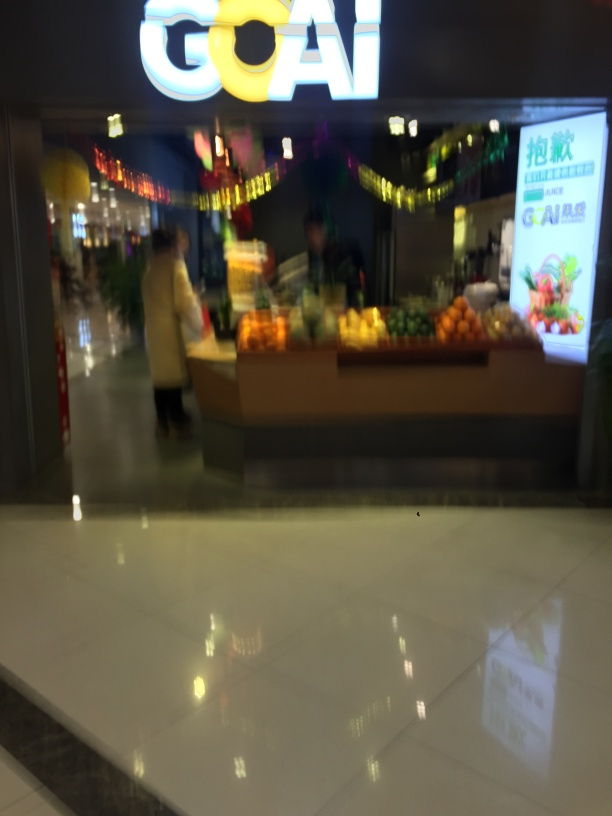Does the image contain noise?
A. no
B. yes
C. maybe
Answer with the option's letter from the given choices directly.
 B. 